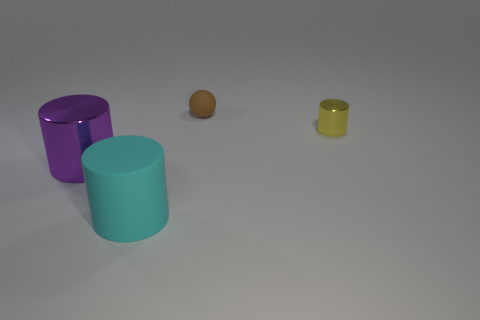What is the shape of the metallic thing that is to the left of the cylinder that is in front of the purple metal object?
Offer a terse response. Cylinder. What number of things are balls or purple objects that are in front of the yellow metallic cylinder?
Provide a succinct answer. 2. What number of other things are the same color as the small metal object?
Offer a very short reply. 0. What number of green objects are either cylinders or matte cylinders?
Ensure brevity in your answer.  0. There is a shiny object right of the metallic thing in front of the small metallic object; are there any spheres behind it?
Your answer should be compact. Yes. Is there anything else that has the same size as the cyan cylinder?
Your answer should be very brief. Yes. What color is the big thing in front of the metallic cylinder that is in front of the tiny metal cylinder?
Your answer should be compact. Cyan. How many small things are yellow things or purple metallic things?
Offer a terse response. 1. What is the color of the object that is to the left of the tiny yellow metallic cylinder and behind the large purple cylinder?
Your answer should be very brief. Brown. Are the cyan thing and the tiny yellow cylinder made of the same material?
Give a very brief answer. No. 